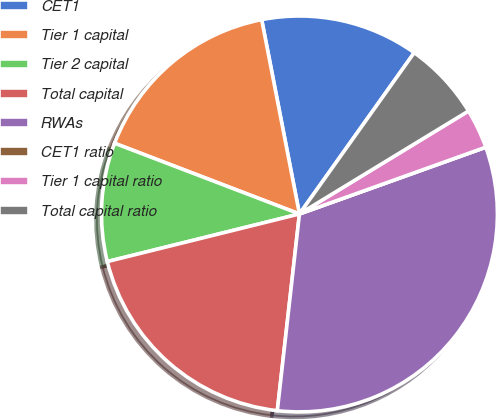Convert chart to OTSL. <chart><loc_0><loc_0><loc_500><loc_500><pie_chart><fcel>CET1<fcel>Tier 1 capital<fcel>Tier 2 capital<fcel>Total capital<fcel>RWAs<fcel>CET1 ratio<fcel>Tier 1 capital ratio<fcel>Total capital ratio<nl><fcel>12.9%<fcel>16.13%<fcel>9.68%<fcel>19.35%<fcel>32.26%<fcel>0.0%<fcel>3.23%<fcel>6.45%<nl></chart> 